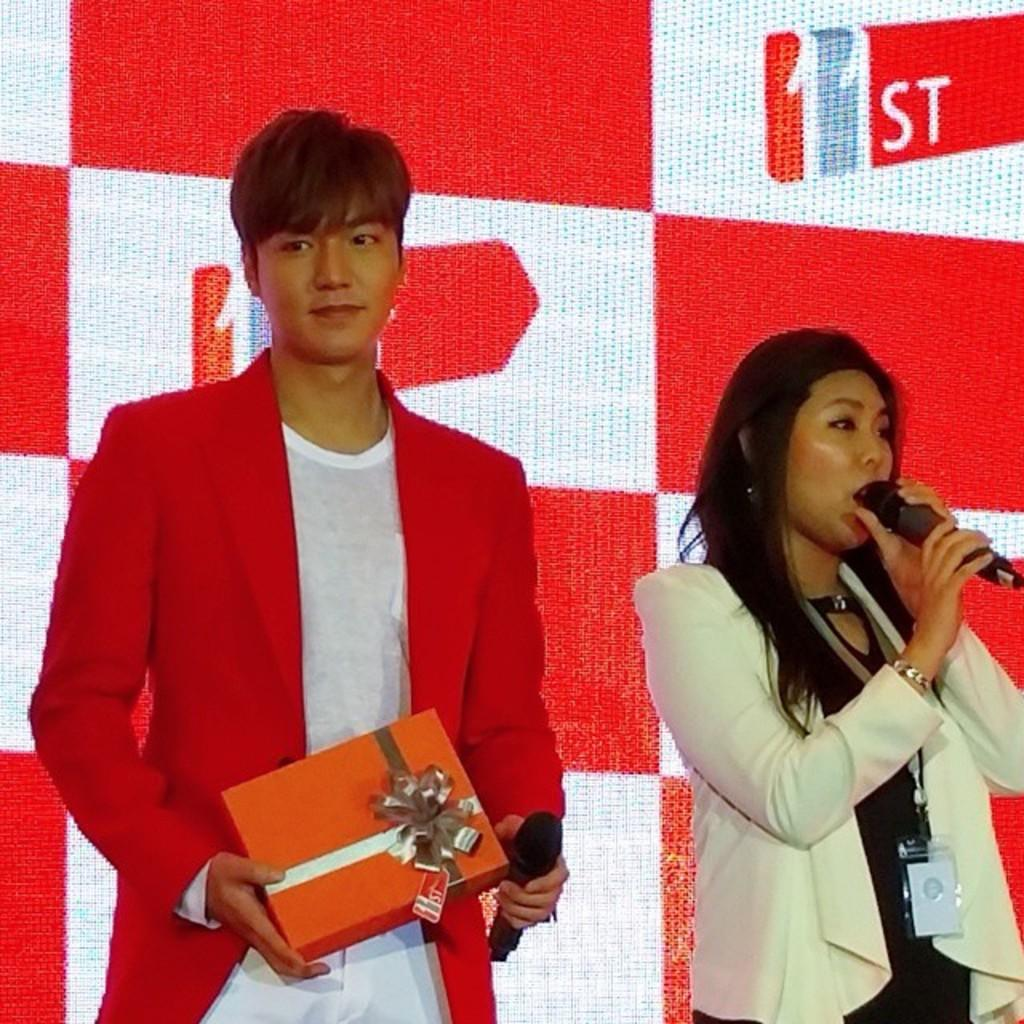How many people are in the image? There are two people standing in the image. What are the people holding in their hands? Both people are holding microphones. Can you describe the man on the left? The man on the left is holding a gift box. What can be seen in the background of the image? There is a board visible in the background of the image. How many dogs are sitting next to the board in the image? There are no dogs present in the image; only two people holding microphones and a man holding a gift box are visible. What type of hook is attached to the board in the image? There is no hook visible in the image; only a board can be seen in the background. 